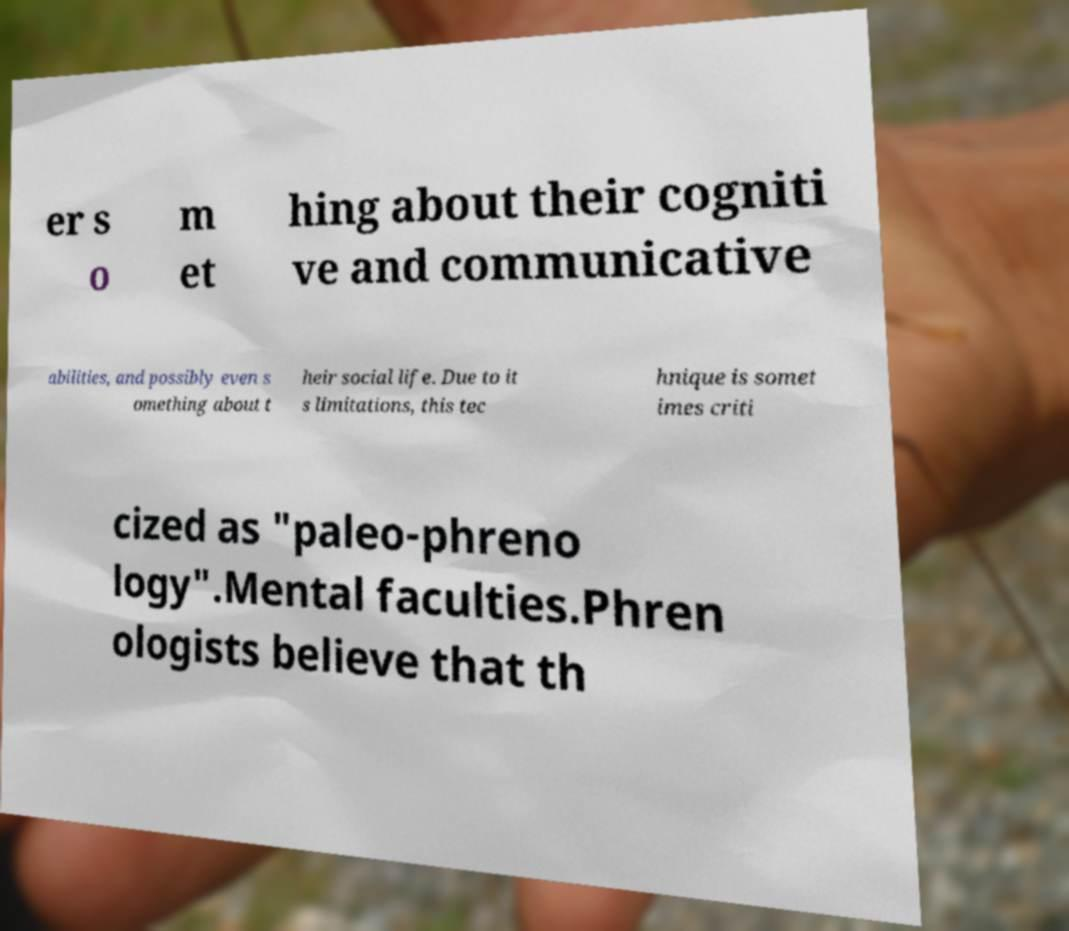Please identify and transcribe the text found in this image. er s o m et hing about their cogniti ve and communicative abilities, and possibly even s omething about t heir social life. Due to it s limitations, this tec hnique is somet imes criti cized as "paleo-phreno logy".Mental faculties.Phren ologists believe that th 